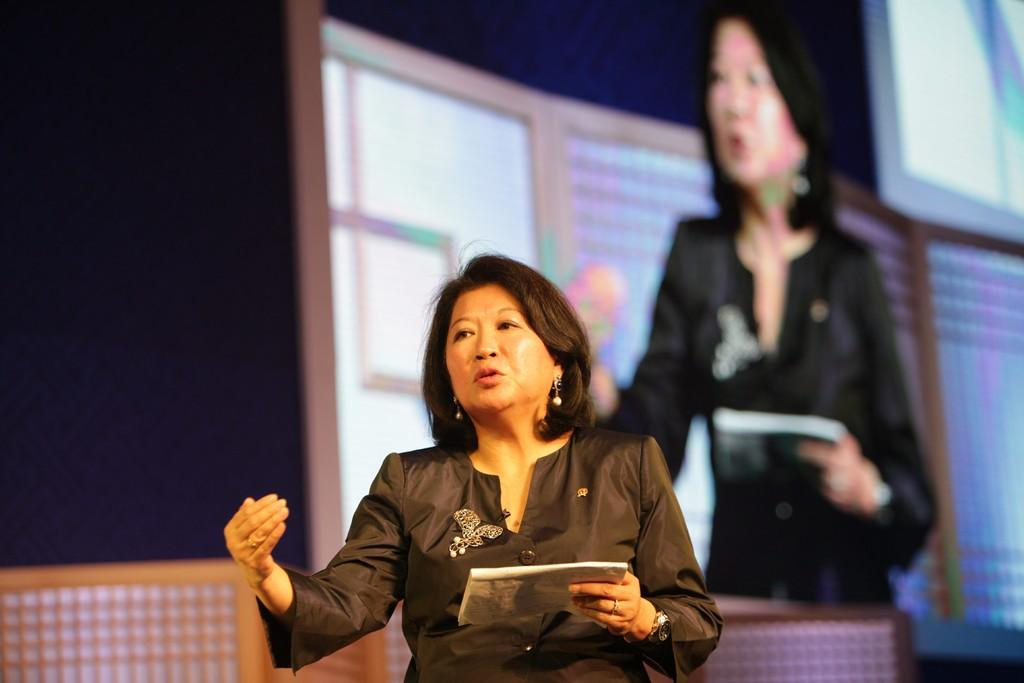Who is the main subject in the image? There is a woman in the image. What is the woman holding in the image? The woman is holding a book. What can be seen in the background of the image? There is a screen in the background of the image. Can you describe the person visible on the screen? Unfortunately, the provided facts do not give any information about the person on the screen. What type of steel is being used to create a flame in the image? There is no steel or flame present in the image. 